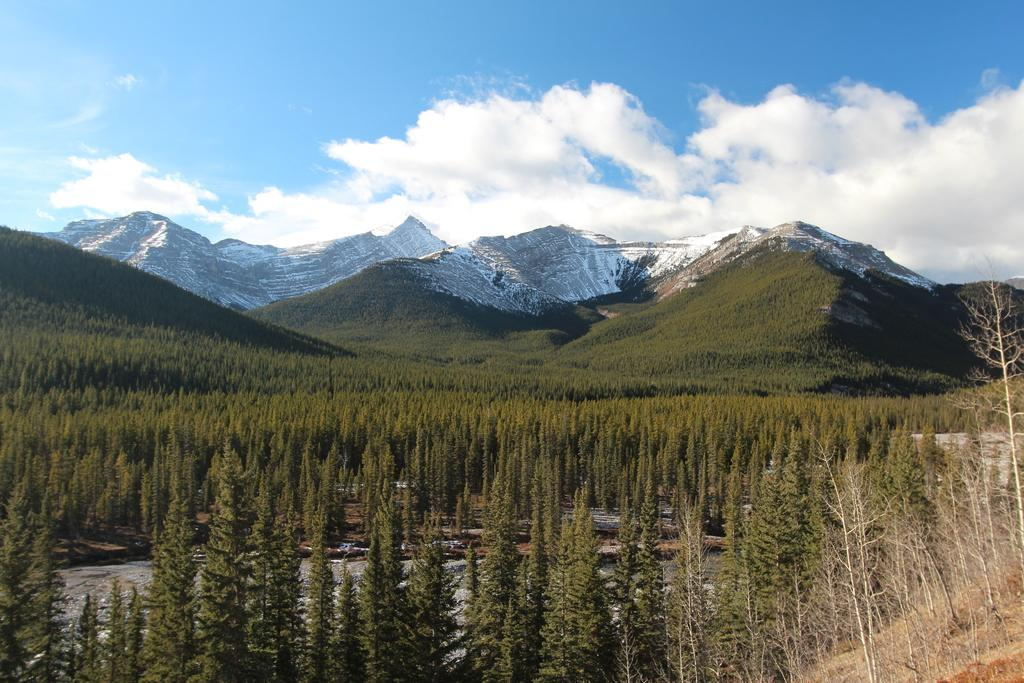What type of vegetation can be seen in the front of the image? There are trees in the front of the image. What type of landscape feature is visible in the background of the image? There are hills visible in the background of the image. What part of the natural environment is visible in the image? The sky is visible in the image. What can be observed in the sky in the image? Clouds are present in the sky. Where is the calendar located in the image? There is no calendar present in the image. What type of agreement is being discussed in the image? There is no discussion of an agreement in the image. 